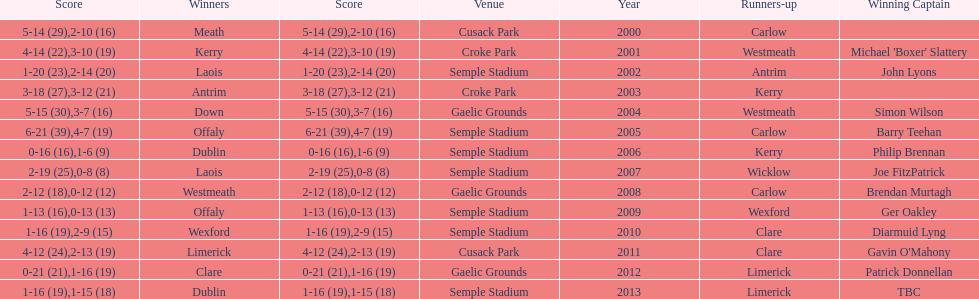Which team was the previous winner before dublin in 2013? Clare. 